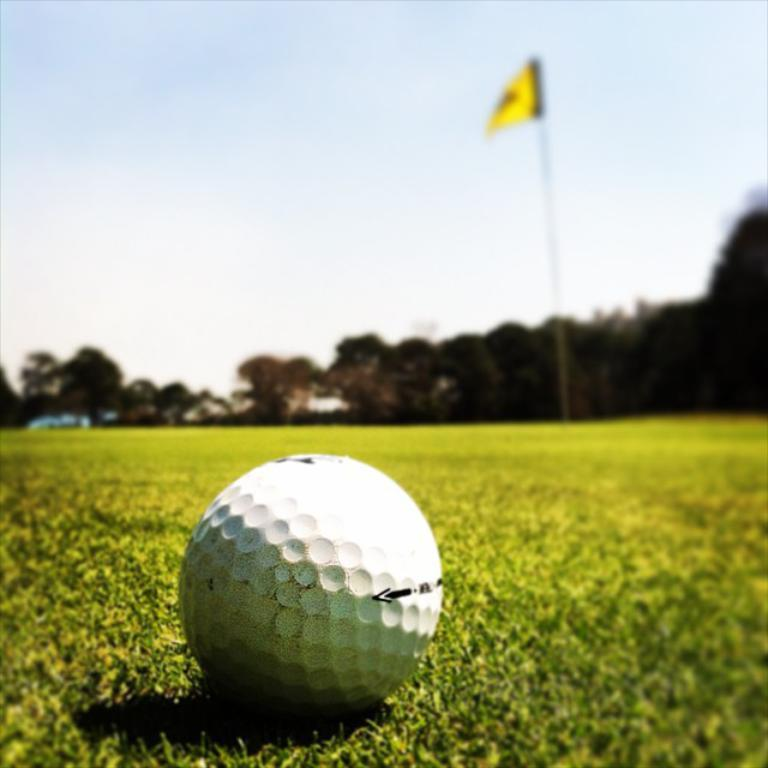What object is on the ground in the image? There is a ball on the ground in the image. What can be seen in the background of the image? There is a flag on a flag post and trees in the background of the image. What is visible in the sky in the image? The sky is visible in the background of the image. What type of spring is attached to the ball in the image? There is no spring attached to the ball in the image. What is the head doing in the image? There is no head present in the image. 